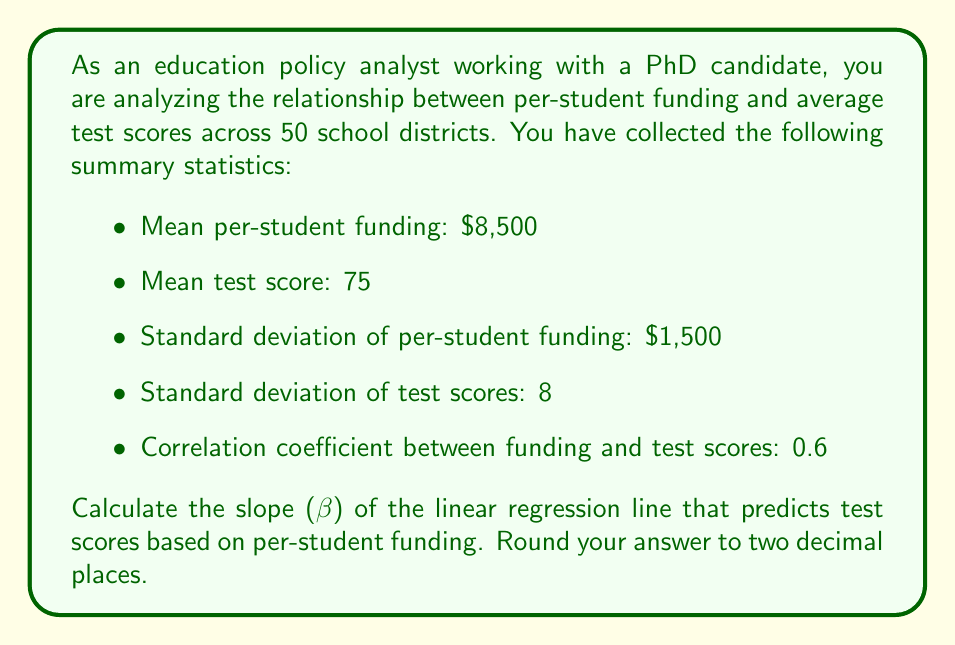Can you solve this math problem? To calculate the slope (β) of the linear regression line, we'll use the formula:

$$ \beta = r \cdot \frac{s_y}{s_x} $$

Where:
- $r$ is the correlation coefficient
- $s_y$ is the standard deviation of the dependent variable (test scores)
- $s_x$ is the standard deviation of the independent variable (per-student funding)

Given:
- $r = 0.6$
- $s_y = 8$ (standard deviation of test scores)
- $s_x = 1500$ (standard deviation of per-student funding)

Let's substitute these values into the formula:

$$ \beta = 0.6 \cdot \frac{8}{1500} $$

Now, let's calculate:

$$ \beta = 0.6 \cdot 0.00533333... $$
$$ \beta = 0.00320 $$

Rounding to two decimal places:

$$ \beta = 0.0032 $$

This means that for every dollar increase in per-student funding, the predicted test score increases by 0.0032 points.
Answer: $0.0032$ 